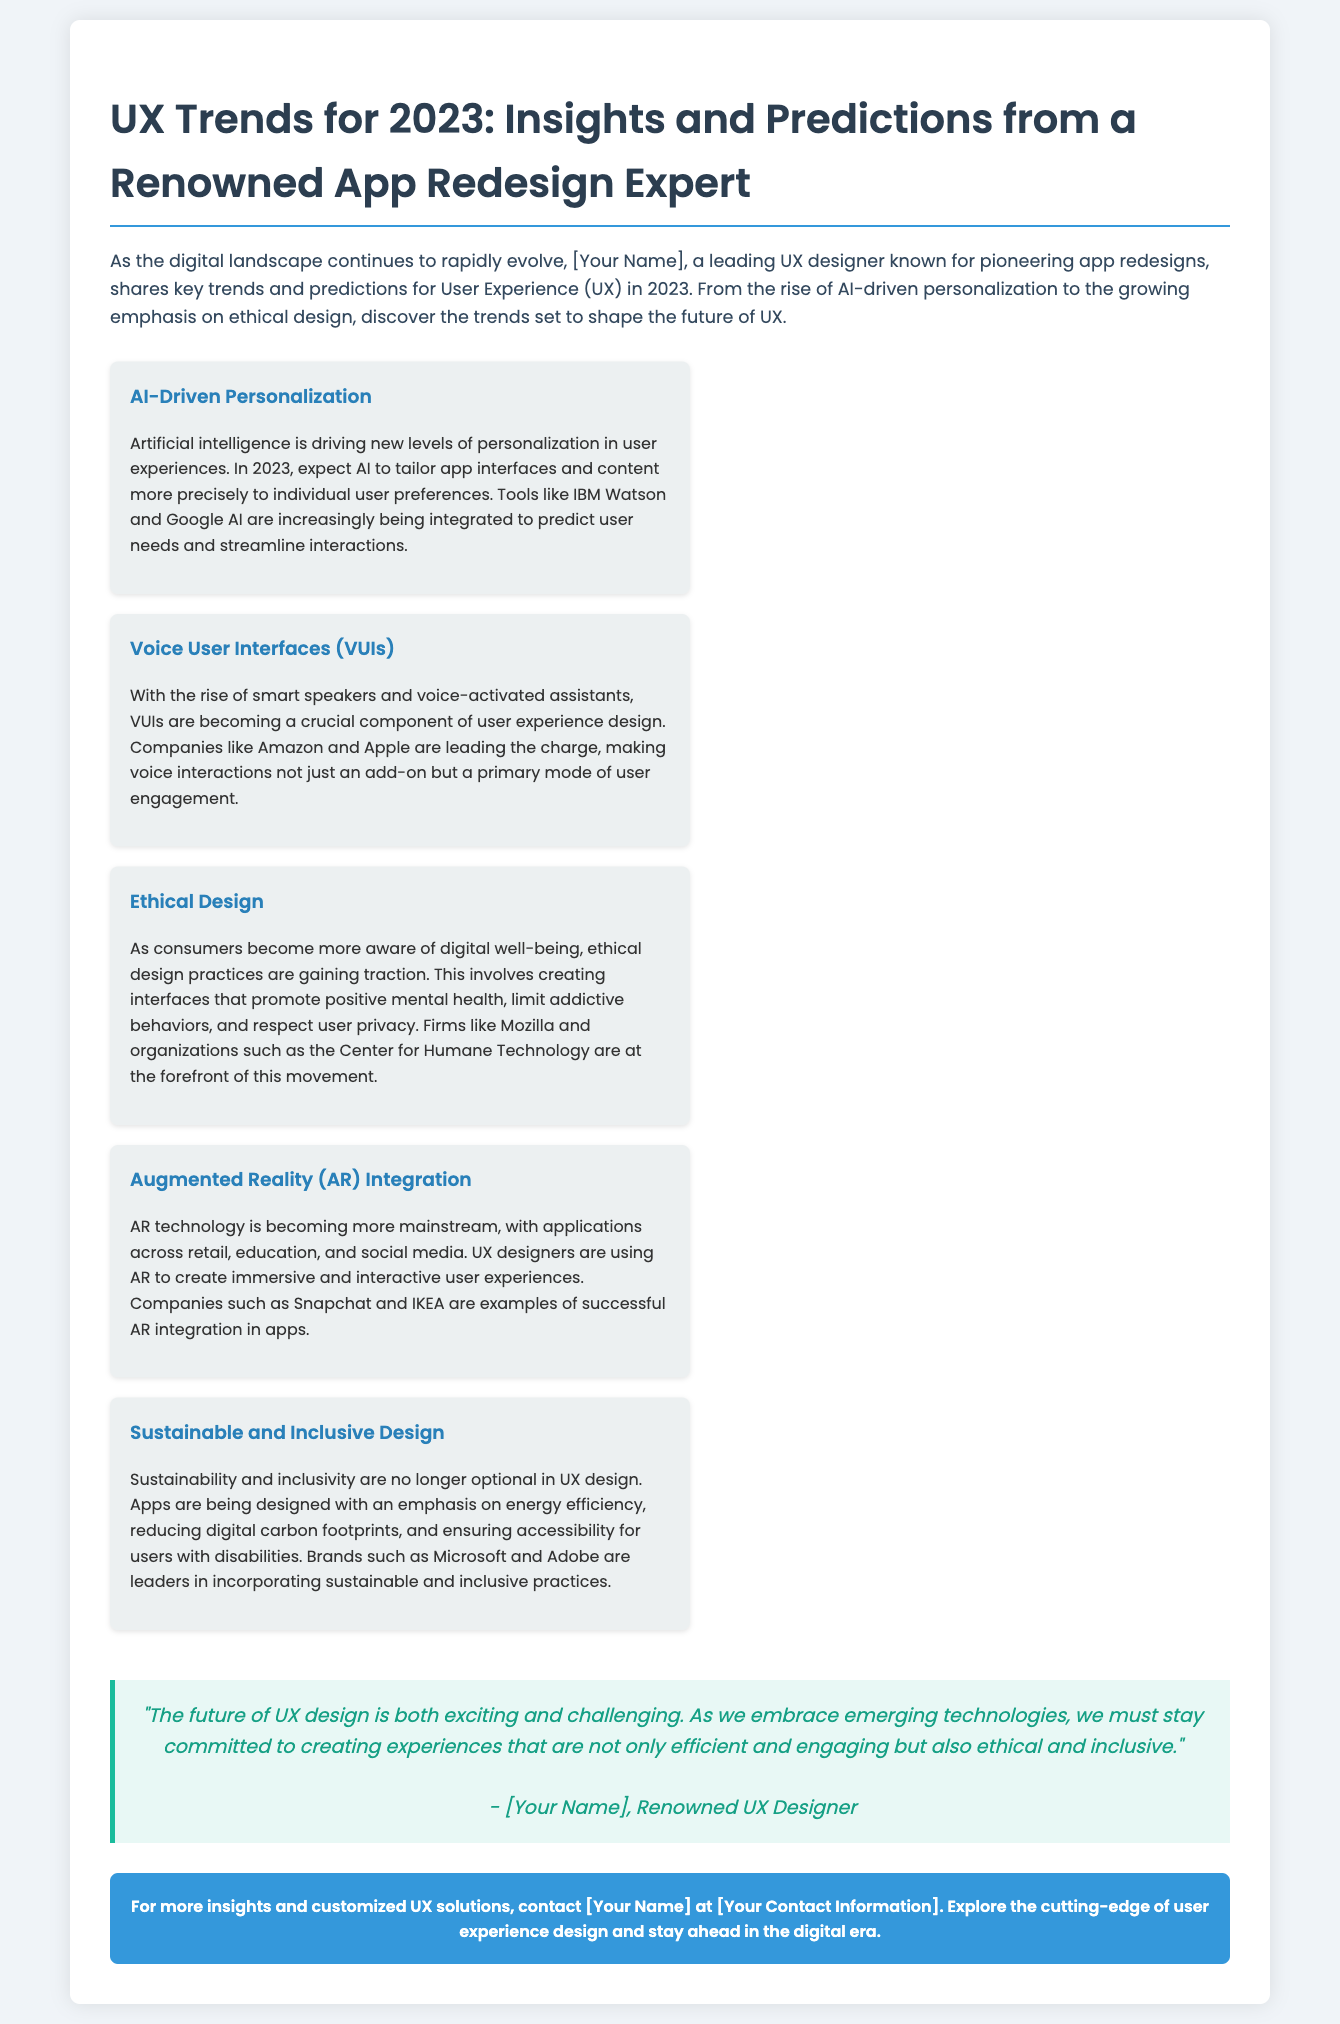What is the title of the press release? The title is provided in the document header.
Answer: UX Trends for 2023: Insights and Predictions from a Renowned App Redesign Expert Who is the renowned UX designer mentioned? The document refers generically to [Your Name], which is a placeholder.
Answer: [Your Name] What are the two key technologies driving 2023 UX trends? The document mentions AI and VUIs as major trends.
Answer: AI and Voice User Interfaces How many key trends are outlined in the document? There are five key trends listed in the document.
Answer: Five Which company is noted for its role in ethical design practices? The document specifies Mozilla as a leading firm in ethical design.
Answer: Mozilla What type of design is emphasized alongside sustainability in UX? The document highlights inclusivity as a crucial aspect of design.
Answer: Inclusivity What quote is attributed to the renowned UX designer? The document includes an inspiring quote about the future of UX design.
Answer: "The future of UX design is both exciting and challenging." What call to action is provided at the end of the document? The document encourages readers to contact for more insights and solutions.
Answer: Contact [Your Name] at [Your Contact Information] 